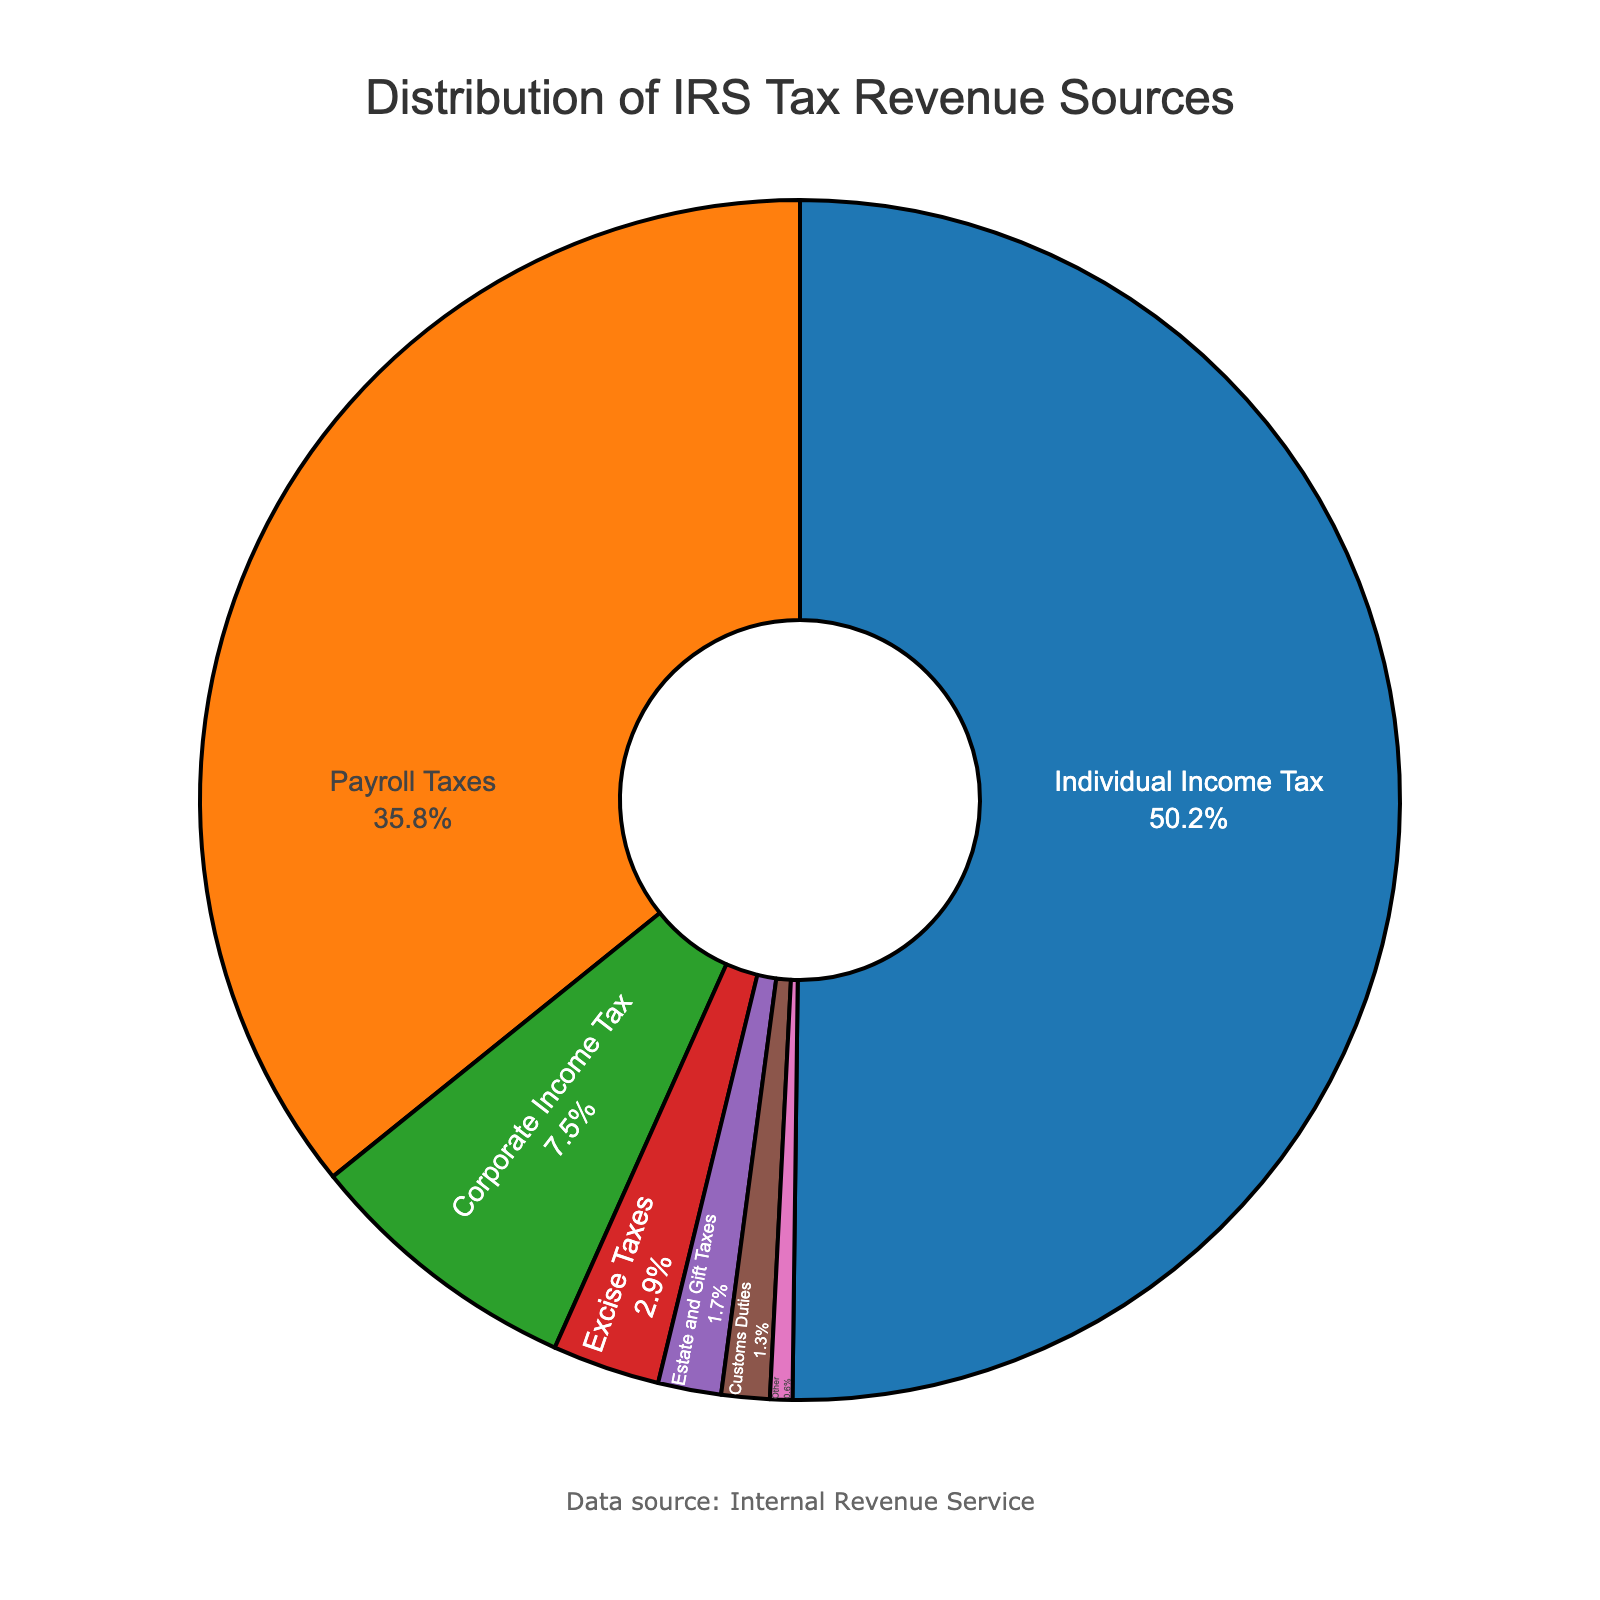Which category contributes the highest percentage to the IRS tax revenue? The category with the highest percentage can be identified by looking at the label with the largest slice in the pie chart. "Individual Income Tax" has the largest slice at 50.2%.
Answer: Individual Income Tax What is the combined percentage of Corporate Income Tax and Excise Taxes? Add the percentages of Corporate Income Tax (7.5%) and Excise Taxes (2.9%) together. 7.5% + 2.9% = 10.4%.
Answer: 10.4% Which category contributes the least to the IRS tax revenue? The smallest slice in the pie chart represents the category with the least contribution, which is "Other" at 0.6%.
Answer: Other How much more does Payroll Taxes contribute compared to Corporate Income Tax? Subtract the percentage of Corporate Income Tax (7.5%) from Payroll Taxes (35.8%). 35.8% - 7.5% = 28.3%.
Answer: 28.3% What is the sum of the contributions from Payroll Taxes and Estate and Gift Taxes? Add the percentages of Payroll Taxes (35.8%) and Estate and Gift Taxes (1.7%). 35.8% + 1.7% = 37.5%.
Answer: 37.5% Which category occupies a smaller percentage of IRS revenue, Excise Taxes or Customs Duties? Compare the percentages of Excise Taxes (2.9%) and Customs Duties (1.3%); Customs Duties is smaller.
Answer: Customs Duties Is the contribution of Individual Income Tax greater than the combined contributions of Payroll Taxes and Corporate Income Tax? Add the percentages of Payroll Taxes (35.8%) and Corporate Income Tax (7.5%). 35.8% + 7.5% = 43.3%. Individual Income Tax is 50.2%, which is greater than 43.3%.
Answer: Yes How much does Estate and Gift Taxes contribute more than Customs Duties? Subtract the percentage of Customs Duties (1.3%) from Estate and Gift Taxes (1.7%). 1.7% - 1.3% = 0.4%.
Answer: 0.4% What percentage of IRS revenue is contributed by categories other than Individual Income Tax? Subtract the percentage of Individual Income Tax (50.2%) from 100%. 100% - 50.2% = 49.8%.
Answer: 49.8% 